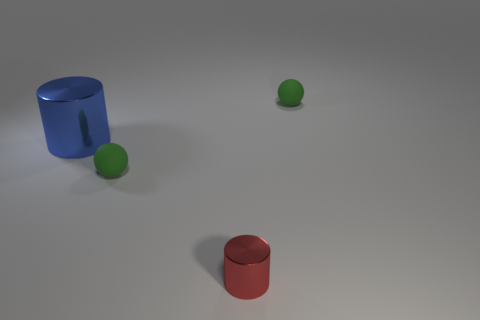Add 1 red cylinders. How many objects exist? 5 Subtract all blue shiny cylinders. Subtract all tiny cylinders. How many objects are left? 2 Add 3 tiny green balls. How many tiny green balls are left? 5 Add 3 small metal cylinders. How many small metal cylinders exist? 4 Subtract 0 purple cylinders. How many objects are left? 4 